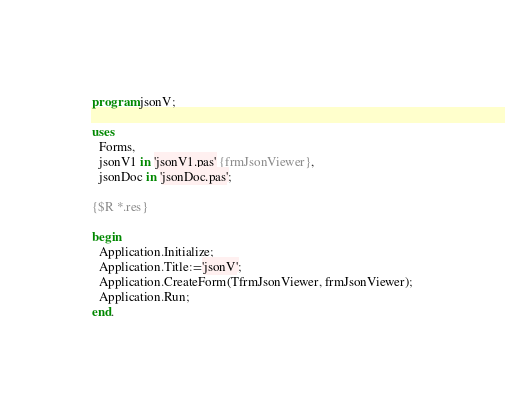Convert code to text. <code><loc_0><loc_0><loc_500><loc_500><_Pascal_>program jsonV;

uses
  Forms,
  jsonV1 in 'jsonV1.pas' {frmJsonViewer},
  jsonDoc in 'jsonDoc.pas';

{$R *.res}

begin
  Application.Initialize;
  Application.Title:='jsonV';
  Application.CreateForm(TfrmJsonViewer, frmJsonViewer);
  Application.Run;     
end.
</code> 